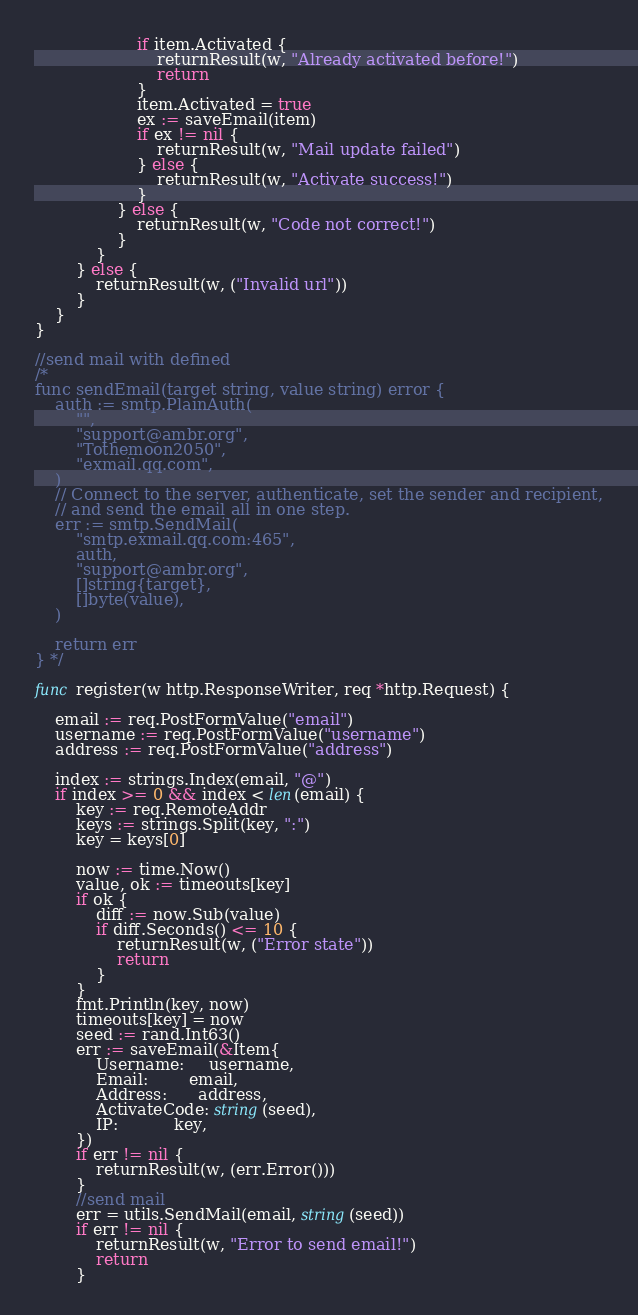Convert code to text. <code><loc_0><loc_0><loc_500><loc_500><_Go_>					if item.Activated {
						returnResult(w, "Already activated before!")
						return
					}
					item.Activated = true
					ex := saveEmail(item)
					if ex != nil {
						returnResult(w, "Mail update failed")
					} else {
						returnResult(w, "Activate success!")
					}
				} else {
					returnResult(w, "Code not correct!")
				}
			}
		} else {
			returnResult(w, ("Invalid url"))
		}
	}
}

//send mail with defined
/*
func sendEmail(target string, value string) error {
	auth := smtp.PlainAuth(
		"",
		"support@ambr.org",
		"Tothemoon2050",
		"exmail.qq.com",
	)
	// Connect to the server, authenticate, set the sender and recipient,
	// and send the email all in one step.
	err := smtp.SendMail(
		"smtp.exmail.qq.com:465",
		auth,
		"support@ambr.org",
		[]string{target},
		[]byte(value),
	)

	return err
} */

func register(w http.ResponseWriter, req *http.Request) {

	email := req.PostFormValue("email")
	username := req.PostFormValue("username")
	address := req.PostFormValue("address")

	index := strings.Index(email, "@")
	if index >= 0 && index < len(email) {
		key := req.RemoteAddr
		keys := strings.Split(key, ":")
		key = keys[0]

		now := time.Now()
		value, ok := timeouts[key]
		if ok {
			diff := now.Sub(value)
			if diff.Seconds() <= 10 {
				returnResult(w, ("Error state"))
				return
			}
		}
		fmt.Println(key, now)
		timeouts[key] = now
		seed := rand.Int63()
		err := saveEmail(&Item{
			Username:     username,
			Email:        email,
			Address:      address,
			ActivateCode: string(seed),
			IP:           key,
		})
		if err != nil {
			returnResult(w, (err.Error()))
		}
		//send mail
		err = utils.SendMail(email, string(seed))
		if err != nil {
			returnResult(w, "Error to send email!")
			return
		}
</code> 